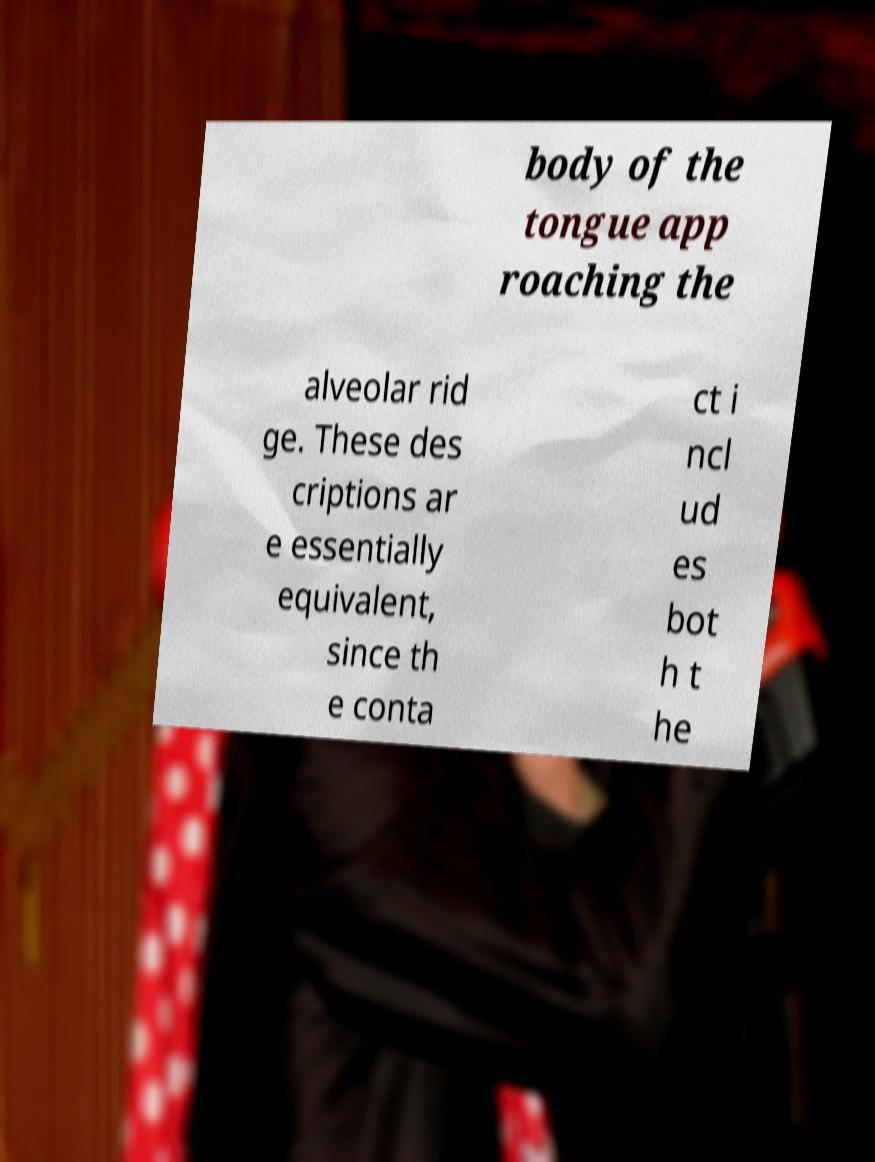Could you assist in decoding the text presented in this image and type it out clearly? body of the tongue app roaching the alveolar rid ge. These des criptions ar e essentially equivalent, since th e conta ct i ncl ud es bot h t he 